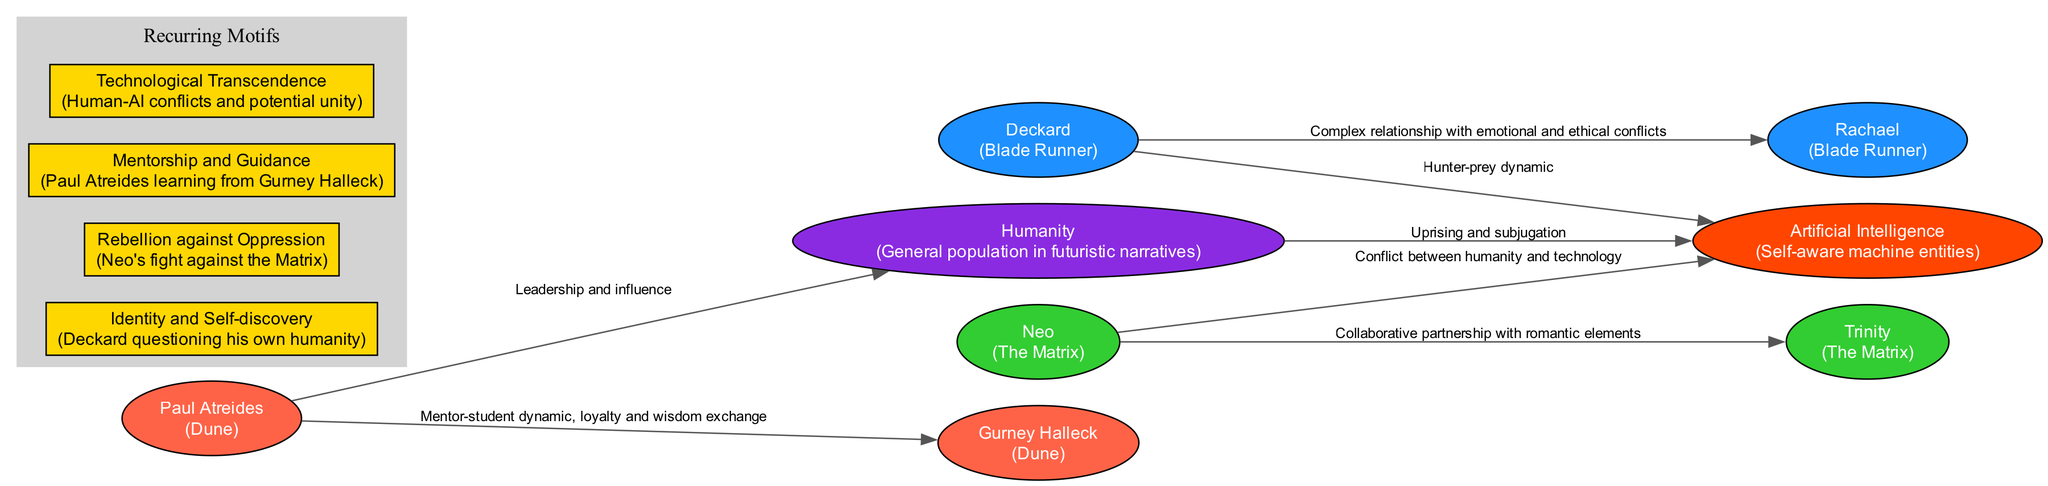What is the total number of characters represented in the diagram? The diagram contains eight nodes representing different characters from futuristic fiction; after counting each node, the total is confirmed to be eight.
Answer: 8 What relationship is depicted between Deckard and Rachael? The diagram shows a complex relationship between Deckard and Rachael that includes emotional and ethical conflicts; this information is directly provided in the edge label connecting these two nodes.
Answer: Complex relationship with emotional and ethical conflicts Who has a mentor-student dynamic in the diagram? The relationship between Paul Atreides and Gurney Halleck is labeled as a mentor-student dynamic, indicating that this specific edge connects these two characters.
Answer: Paul Atreides and Gurney Halleck Which characters are involved in a conflict between humanity and technology? The edge between Neo and Artificial Intelligence indicates there is a conflict between these two; thus, examining these nodes shows their specific involvement in this theme.
Answer: Neo and Artificial Intelligence How many edges are present in the diagram? By counting the edges connecting the character nodes, the diagram includes six edges that represent various relationships between characters.
Answer: 6 What motif is represented by Neo's fight against the Matrix? The motif of rebellion against oppression is explicitly mentioned as an example in the diagram, connecting it directly to Neo's actions within the narrative.
Answer: Rebellion against Oppression What type of relationship exists between Neo and Trinity? The diagram illustrates that Neo and Trinity share a collaborative partnership, with romantic elements; this relationship is denoted in the edge label connecting the two.
Answer: Collaborative partnership with romantic elements Which character describes the general population in futuristic narratives? Humanity is identified as representing the general population in futuristic narratives within the diagram's nodes; the label directly denotes this classification.
Answer: Humanity What is a key theme depicted in the relationship between humanity and artificial intelligence? The diagram represents the theme of uprising and subjugation, indicating a struggle between these two entities as highlighted in the edge label.
Answer: Uprising and subjugation 